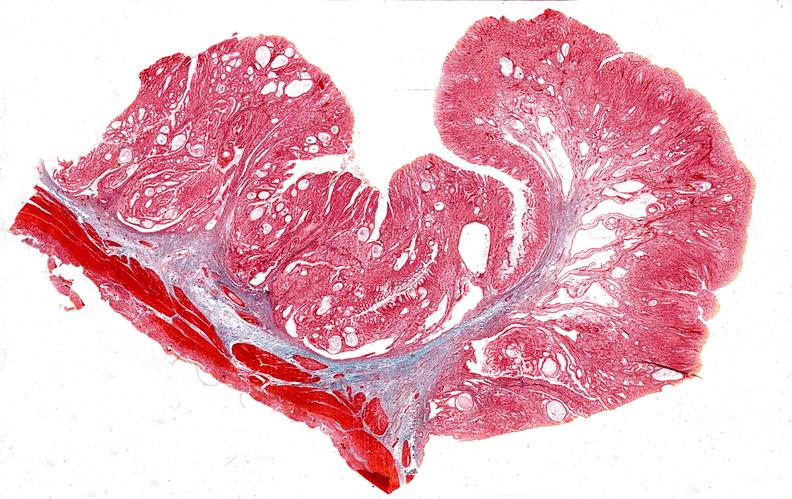s foot present?
Answer the question using a single word or phrase. No 